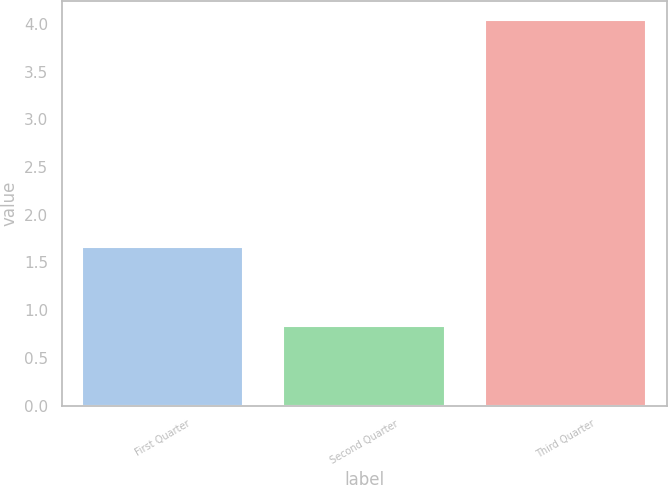Convert chart. <chart><loc_0><loc_0><loc_500><loc_500><bar_chart><fcel>First Quarter<fcel>Second Quarter<fcel>Third Quarter<nl><fcel>1.66<fcel>0.83<fcel>4.04<nl></chart> 